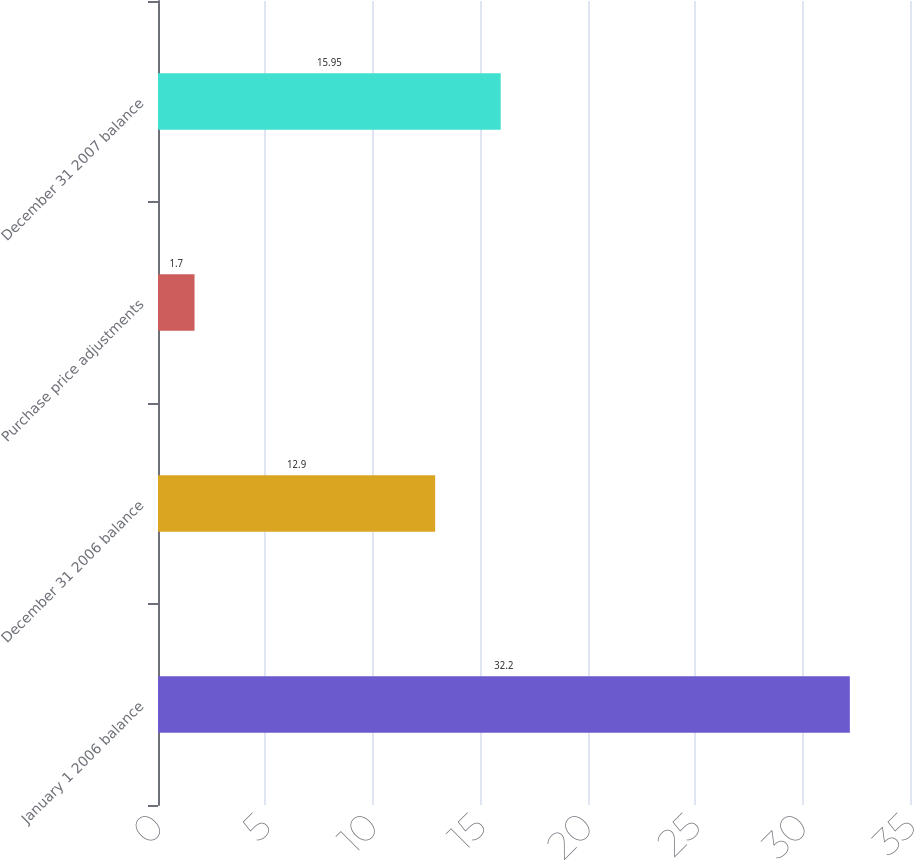Convert chart. <chart><loc_0><loc_0><loc_500><loc_500><bar_chart><fcel>January 1 2006 balance<fcel>December 31 2006 balance<fcel>Purchase price adjustments<fcel>December 31 2007 balance<nl><fcel>32.2<fcel>12.9<fcel>1.7<fcel>15.95<nl></chart> 